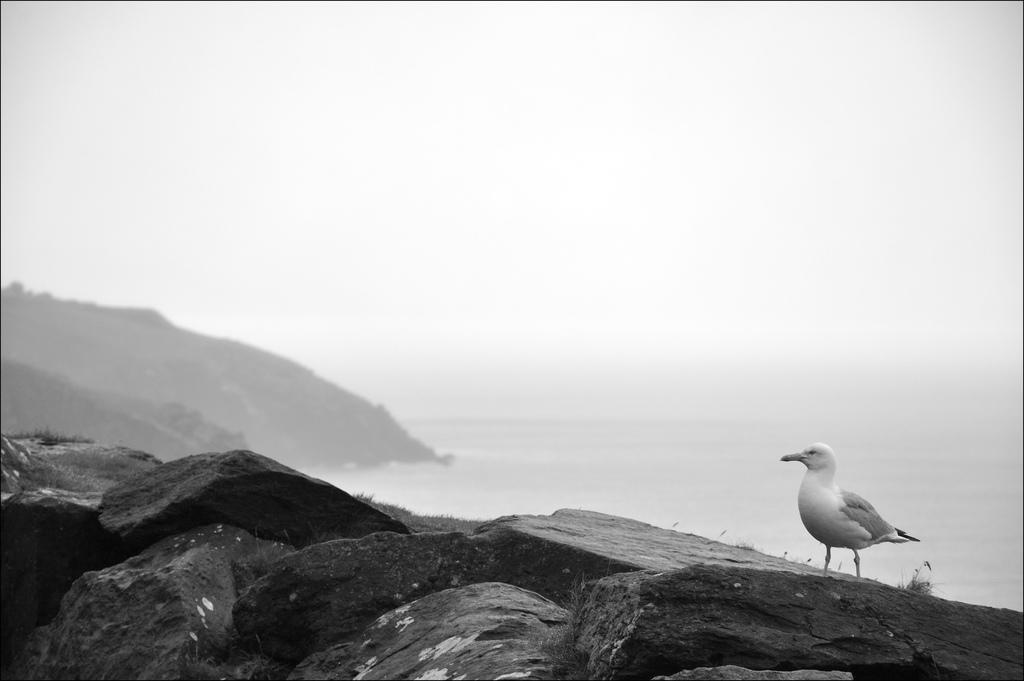What is located in the center of the image? There are stones in the center of the image. Is there any wildlife visible in the image? Yes, there is a white-colored bird on one of the stones. What can be seen in the background of the image? The sky, clouds, a hill, and water are visible in the background of the image. Can you tell me how many wheels are visible in the image? There are no wheels present in the image. What type of rat can be seen climbing on the stones in the image? There is no rat present in the image; it features a white-colored bird on one of the stones. 